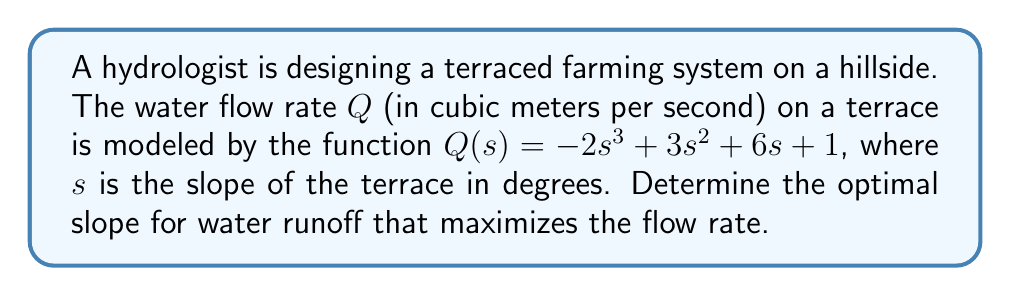Show me your answer to this math problem. To find the optimal slope that maximizes the flow rate, we need to find the maximum of the function $Q(s)$. This can be done by following these steps:

1. Find the derivative of $Q(s)$ with respect to $s$:
   $$Q'(s) = -6s^2 + 6s + 6$$

2. Set the derivative equal to zero to find critical points:
   $$-6s^2 + 6s + 6 = 0$$

3. Factor the equation:
   $$-6(s^2 - s - 1) = 0$$
   $$-6(s - \frac{1+\sqrt{5}}{2})(s - \frac{1-\sqrt{5}}{2}) = 0$$

4. Solve for $s$:
   $$s_1 = \frac{1+\sqrt{5}}{2} \approx 1.618$$
   $$s_2 = \frac{1-\sqrt{5}}{2} \approx -0.618$$

5. Since the slope cannot be negative in this context, we discard the negative solution.

6. To confirm this is a maximum, we can check the second derivative:
   $$Q''(s) = -12s + 6$$
   At $s = \frac{1+\sqrt{5}}{2}$:
   $$Q''(\frac{1+\sqrt{5}}{2}) = -12(\frac{1+\sqrt{5}}{2}) + 6 = -6\sqrt{5} < 0$$

Since the second derivative is negative at this point, it confirms that this is a local maximum.

Therefore, the optimal slope for water runoff that maximizes the flow rate is approximately 1.618 degrees.
Answer: $\frac{1+\sqrt{5}}{2} \approx 1.618$ degrees 